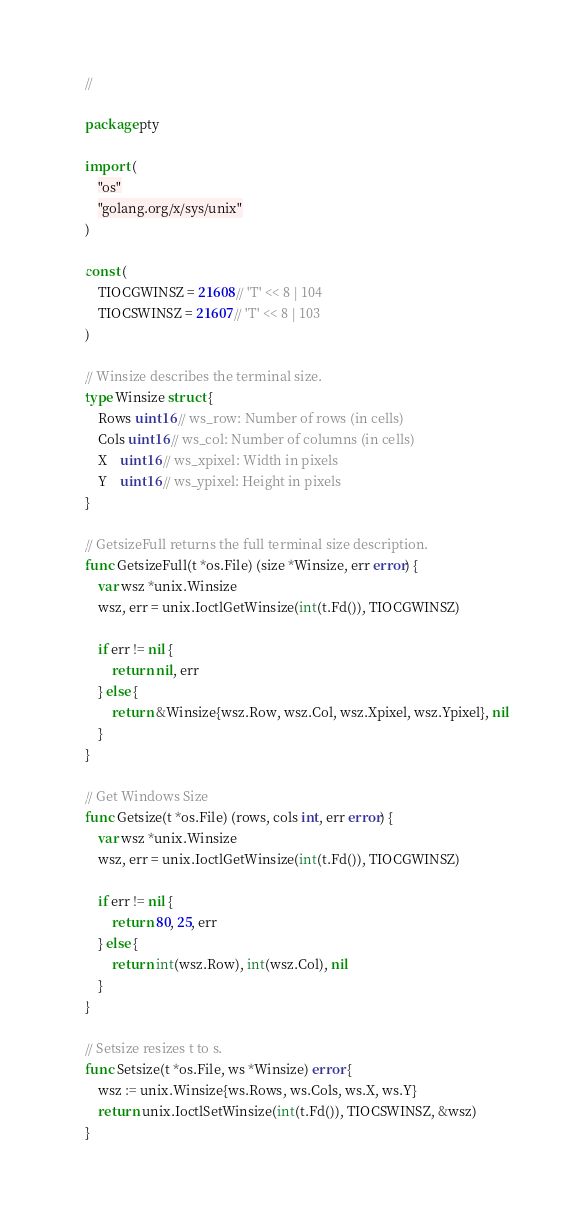<code> <loc_0><loc_0><loc_500><loc_500><_Go_>//

package pty

import (
	"os"
	"golang.org/x/sys/unix"
)

const (
	TIOCGWINSZ = 21608 // 'T' << 8 | 104
	TIOCSWINSZ = 21607 // 'T' << 8 | 103
)

// Winsize describes the terminal size.
type Winsize struct {
	Rows uint16 // ws_row: Number of rows (in cells)
	Cols uint16 // ws_col: Number of columns (in cells)
	X    uint16 // ws_xpixel: Width in pixels
	Y    uint16 // ws_ypixel: Height in pixels
}

// GetsizeFull returns the full terminal size description.
func GetsizeFull(t *os.File) (size *Winsize, err error) {
	var wsz *unix.Winsize
	wsz, err = unix.IoctlGetWinsize(int(t.Fd()), TIOCGWINSZ)

	if err != nil {
		return nil, err
	} else {
		return &Winsize{wsz.Row, wsz.Col, wsz.Xpixel, wsz.Ypixel}, nil
	}
}

// Get Windows Size
func Getsize(t *os.File) (rows, cols int, err error) {
	var wsz *unix.Winsize
	wsz, err = unix.IoctlGetWinsize(int(t.Fd()), TIOCGWINSZ)

	if err != nil {
		return 80, 25, err
	} else {
		return int(wsz.Row), int(wsz.Col), nil
	}
}

// Setsize resizes t to s.
func Setsize(t *os.File, ws *Winsize) error {
	wsz := unix.Winsize{ws.Rows, ws.Cols, ws.X, ws.Y}
	return unix.IoctlSetWinsize(int(t.Fd()), TIOCSWINSZ, &wsz)
}
</code> 